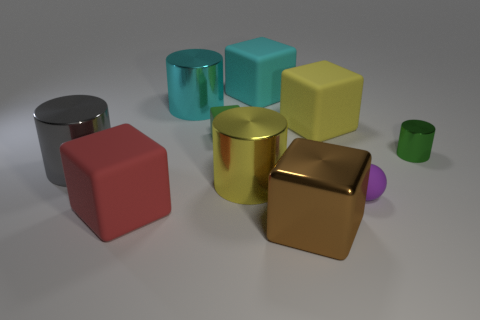There is a green object that is the same shape as the big yellow matte object; what is its size?
Offer a terse response. Small. Is the color of the small block the same as the tiny cylinder?
Ensure brevity in your answer.  Yes. What color is the tiny shiny cylinder?
Your answer should be very brief. Green. How many objects are matte cubes left of the cyan cylinder or large cyan matte things?
Keep it short and to the point. 2. Is the size of the cyan thing that is to the left of the cyan matte thing the same as the metal cylinder to the right of the yellow metal cylinder?
Give a very brief answer. No. What number of objects are either things on the left side of the big yellow cylinder or big yellow things that are in front of the gray metallic object?
Give a very brief answer. 5. Does the large gray cylinder have the same material as the cyan thing in front of the cyan block?
Your answer should be very brief. Yes. The small thing that is behind the purple rubber ball and right of the yellow rubber object has what shape?
Offer a terse response. Cylinder. How many other objects are there of the same color as the shiny block?
Make the answer very short. 0. What is the shape of the purple rubber object?
Make the answer very short. Sphere. 